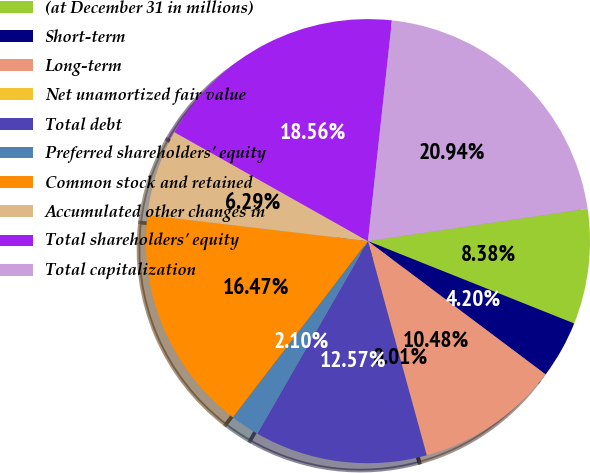Convert chart. <chart><loc_0><loc_0><loc_500><loc_500><pie_chart><fcel>(at December 31 in millions)<fcel>Short-term<fcel>Long-term<fcel>Net unamortized fair value<fcel>Total debt<fcel>Preferred shareholders' equity<fcel>Common stock and retained<fcel>Accumulated other changes in<fcel>Total shareholders' equity<fcel>Total capitalization<nl><fcel>8.38%<fcel>4.2%<fcel>10.48%<fcel>0.01%<fcel>12.57%<fcel>2.1%<fcel>16.47%<fcel>6.29%<fcel>18.56%<fcel>20.94%<nl></chart> 